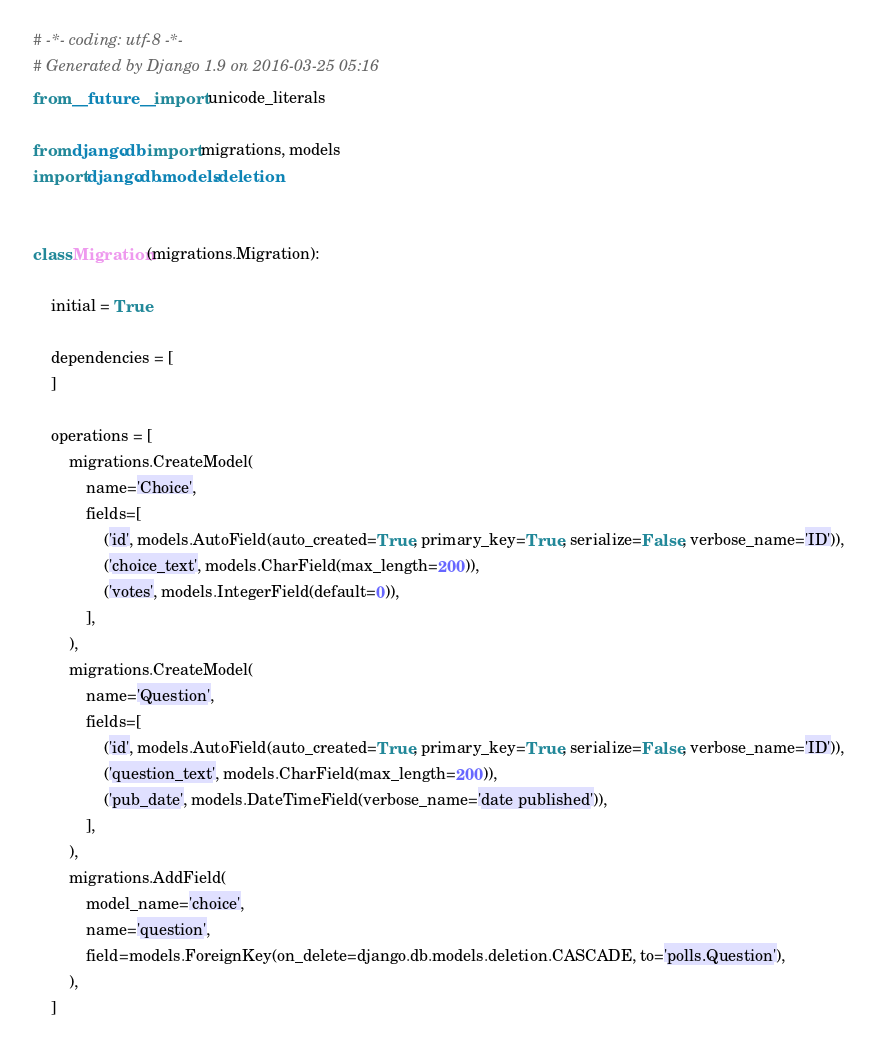<code> <loc_0><loc_0><loc_500><loc_500><_Python_># -*- coding: utf-8 -*-
# Generated by Django 1.9 on 2016-03-25 05:16
from __future__ import unicode_literals

from django.db import migrations, models
import django.db.models.deletion


class Migration(migrations.Migration):

    initial = True

    dependencies = [
    ]

    operations = [
        migrations.CreateModel(
            name='Choice',
            fields=[
                ('id', models.AutoField(auto_created=True, primary_key=True, serialize=False, verbose_name='ID')),
                ('choice_text', models.CharField(max_length=200)),
                ('votes', models.IntegerField(default=0)),
            ],
        ),
        migrations.CreateModel(
            name='Question',
            fields=[
                ('id', models.AutoField(auto_created=True, primary_key=True, serialize=False, verbose_name='ID')),
                ('question_text', models.CharField(max_length=200)),
                ('pub_date', models.DateTimeField(verbose_name='date published')),
            ],
        ),
        migrations.AddField(
            model_name='choice',
            name='question',
            field=models.ForeignKey(on_delete=django.db.models.deletion.CASCADE, to='polls.Question'),
        ),
    ]
</code> 